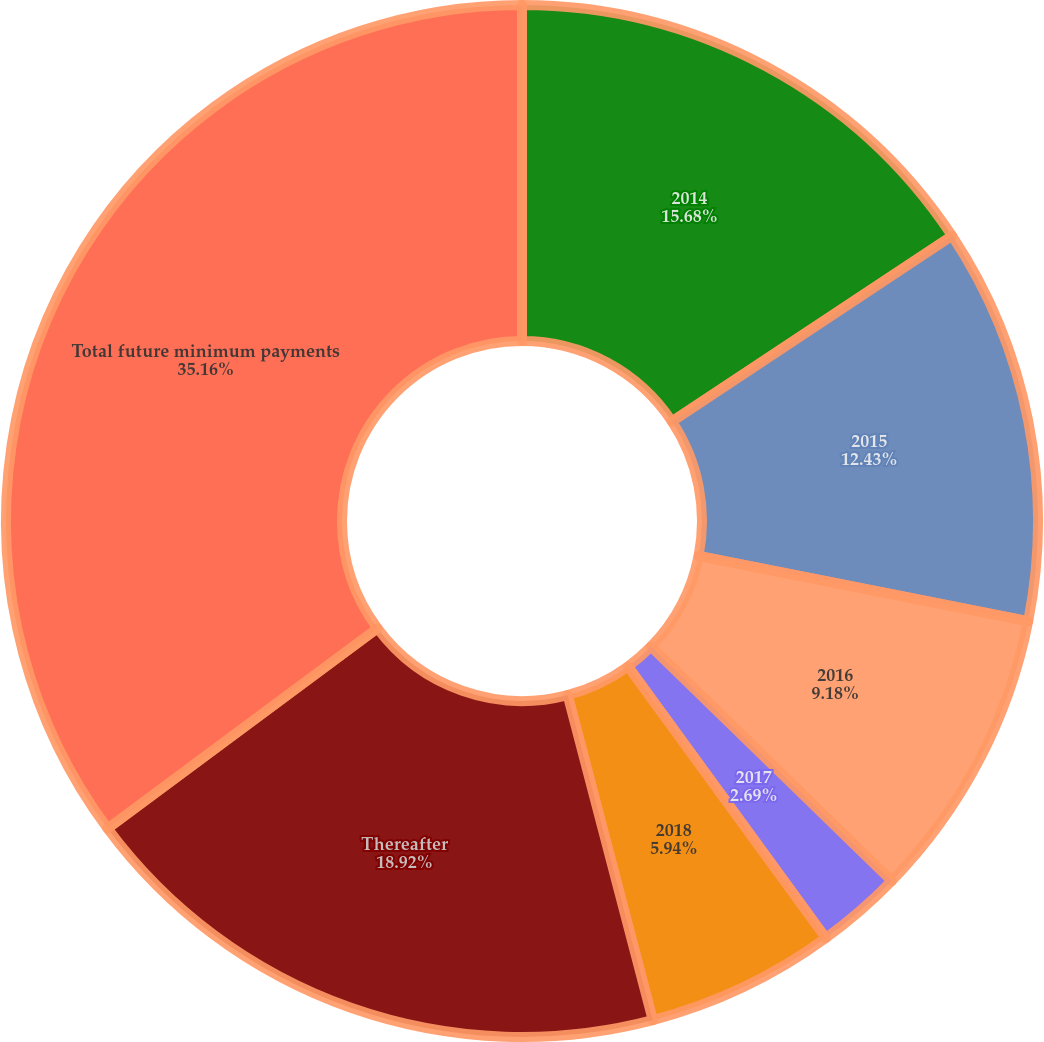Convert chart. <chart><loc_0><loc_0><loc_500><loc_500><pie_chart><fcel>2014<fcel>2015<fcel>2016<fcel>2017<fcel>2018<fcel>Thereafter<fcel>Total future minimum payments<nl><fcel>15.68%<fcel>12.43%<fcel>9.18%<fcel>2.69%<fcel>5.94%<fcel>18.92%<fcel>35.16%<nl></chart> 